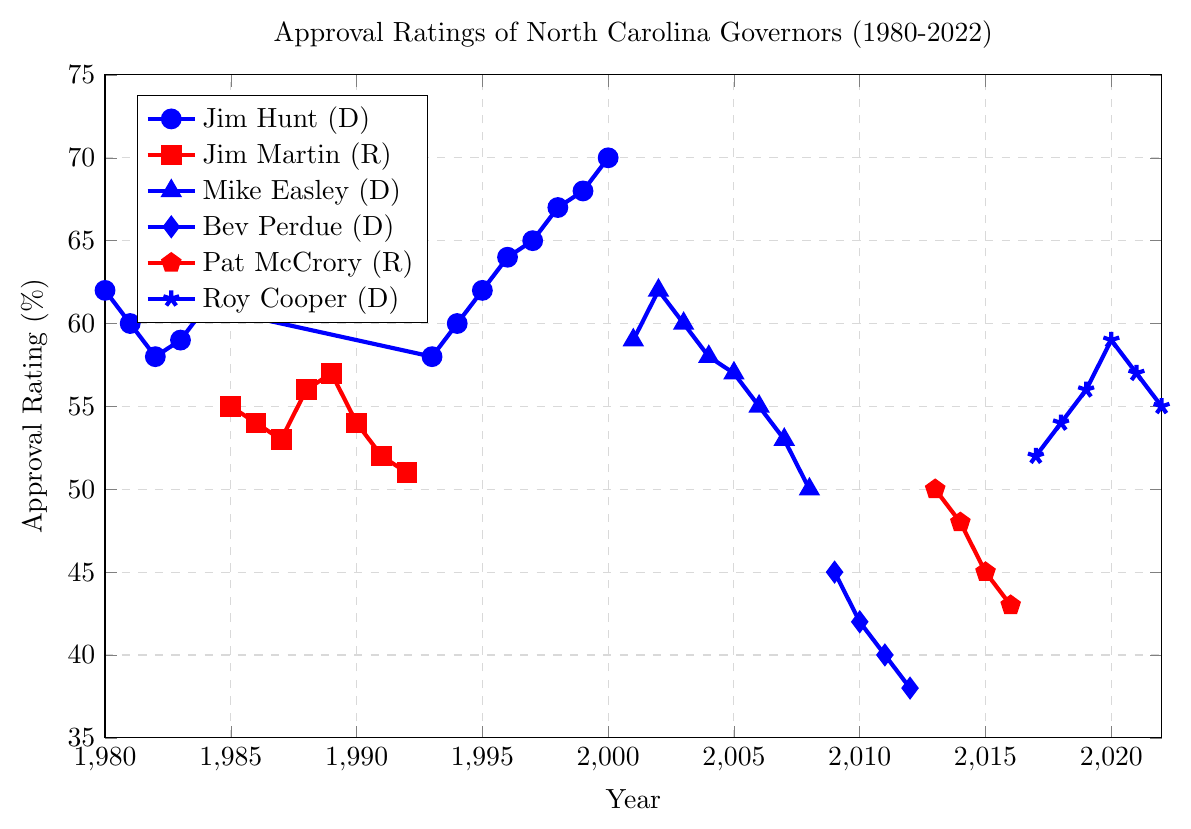Who had the highest approval rating at the end of their term? Roy Cooper had the highest approval rating (59%) at the end of his term in 2020. To identify this, observe the final year ratings of each governor's timeline. Roy Cooper's rating is the highest, outperforming other governors.
Answer: Roy Cooper How did Jim Hunt's approval rating change from 1980 to 2000? Jim Hunt's approval rating in 1980 was 62%. By 2000, it increased to 70%. To determine the change, subtract the initial rating from the final rating (70 - 62). Therefore, the change is an increase of 8%.
Answer: Increased by 8% Which Democratic governor had the lowest starting approval rating, and what was it? Bev Perdue started with the lowest approval rating among Democratic governors at 45% in 2009. This was determined by examining the initial ratings of Democratic governors based on the plot's specific markers.
Answer: Bev Perdue, 45% What was the average approval rating of Republican governors at the beginning of their terms? The starting approval ratings for Republican governors are 55% for Jim Martin and 50% for Pat McCrory. To find the average: (55 + 50) / 2 = 105 / 2 = 52.5%.
Answer: 52.5% Compare the approval ratings of Mike Easley and Pat McCrory at the midpoints of their terms. Mike Easley's midpoint rating (2004) is 58%. Pat McCrory's midpoint rating (2015) is 45%. Mike Easley's midpoint rating is higher. This is identified by checking their approval ratings at their term middle years.
Answer: Mike Easley had a higher midpoint rating Which governor's approval ratings showed the largest decline, and by how much? Bev Perdue's approval rating declined the most, from 45% in 2009 to 38% in 2012. Compute the decline (45 - 38) = 7%.
Answer: Bev Perdue, 7% What is the average approval rating of Jim Hunt during his second term (1993-2000)? Jim Hunt's approval ratings during his second term are: 58, 60, 62, 64, 65, 67, 68, 70. Add these values (58 + 60 + 62 + 64 + 65 + 67 + 68 + 70) = 514. Divide by the number of years (8). The average is 514 / 8 = 64.25%.
Answer: 64.25% How did Roy Cooper's approval rating change from 2017 to 2022? Roy Cooper's approval rating in 2017 was 52%, and by 2022, it was 55%. Compute the change (55 - 52) = 3%, indicating an increase.
Answer: Increased by 3% Which governor experienced a sudden rise in approval rating, and during which years? Jim Hunt experienced a rise from 58% in 1997 to 70% in 2000. By observing the graph, we see a sharp increase during this period.
Answer: Jim Hunt, 1997-2000 Compare the overall trend of approval ratings for Democratic and Republican governors. Democratic governors generally show a fluctuating yet predominantly stable trend with some declines, whereas Republican governors exhibit a steady or declining trend. This is concluded by observing the overall direction and variation in the plot lines for each party color.
Answer: Democratic governors: stable to fluctuating; Republican governors: steady/decline 